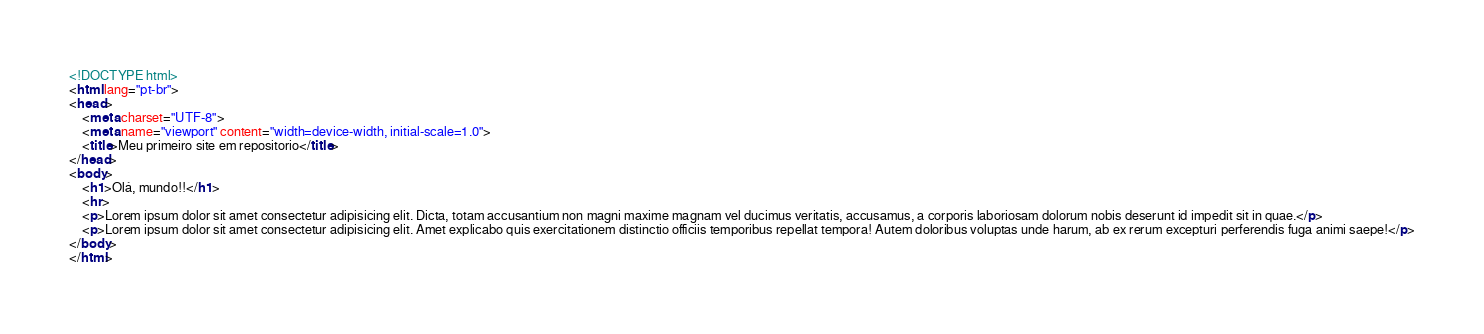<code> <loc_0><loc_0><loc_500><loc_500><_HTML_><!DOCTYPE html>
<html lang="pt-br">
<head>
    <meta charset="UTF-8">
    <meta name="viewport" content="width=device-width, initial-scale=1.0">
    <title>Meu primeiro site em repositorio</title>
</head>
<body>
    <h1>Olá, mundo!!</h1>
    <hr>
    <p>Lorem ipsum dolor sit amet consectetur adipisicing elit. Dicta, totam accusantium non magni maxime magnam vel ducimus veritatis, accusamus, a corporis laboriosam dolorum nobis deserunt id impedit sit in quae.</p>
    <p>Lorem ipsum dolor sit amet consectetur adipisicing elit. Amet explicabo quis exercitationem distinctio officiis temporibus repellat tempora! Autem doloribus voluptas unde harum, ab ex rerum excepturi perferendis fuga animi saepe!</p>
</body>
</html></code> 